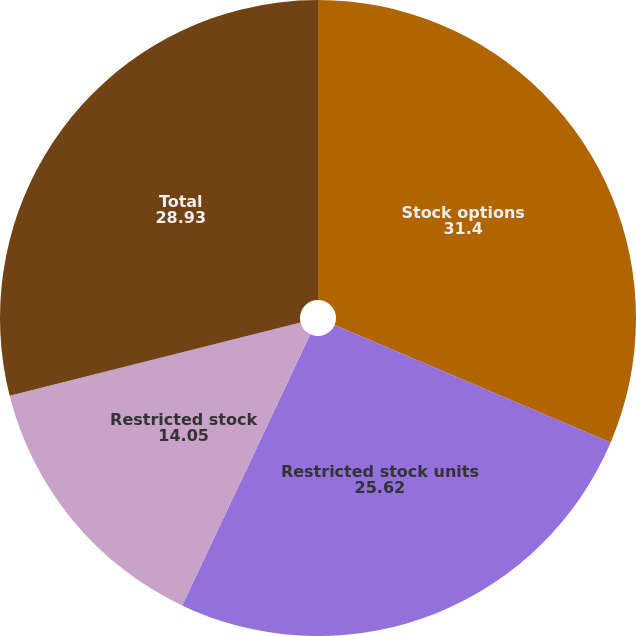<chart> <loc_0><loc_0><loc_500><loc_500><pie_chart><fcel>Stock options<fcel>Restricted stock units<fcel>Restricted stock<fcel>Total<nl><fcel>31.4%<fcel>25.62%<fcel>14.05%<fcel>28.93%<nl></chart> 